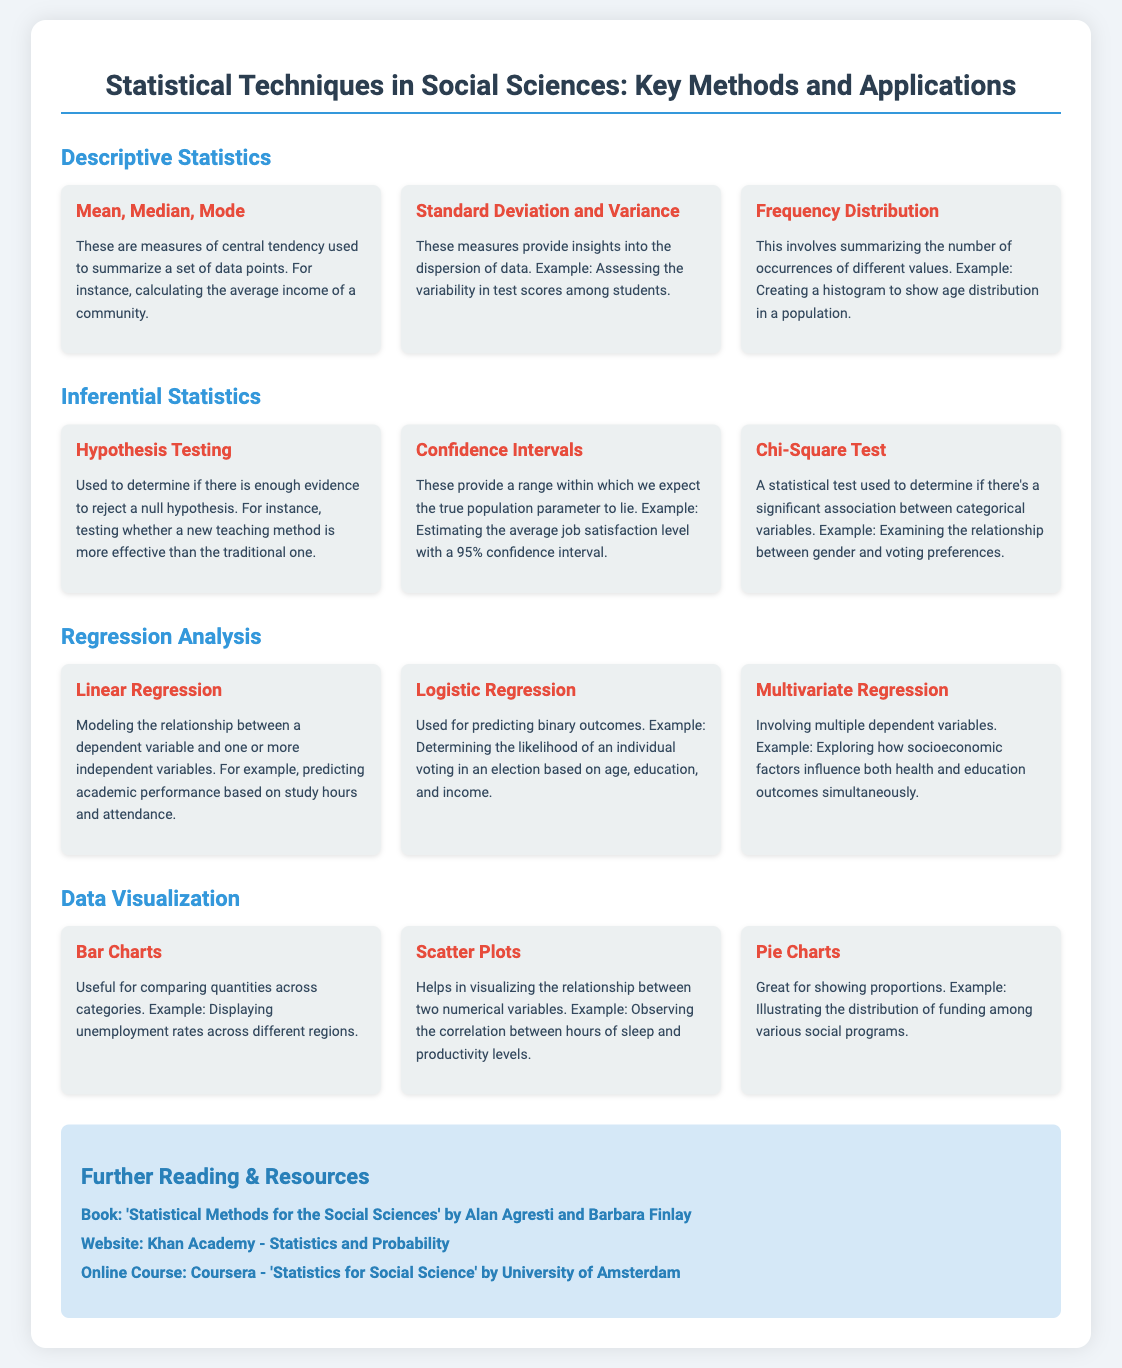What are the three measures of central tendency mentioned? The document lists "Mean, Median, Mode" as the measures of central tendency used to summarize data.
Answer: Mean, Median, Mode What type of statistical test is used to evaluate a null hypothesis? The poster describes "Hypothesis Testing" as a method to determine if there is enough evidence to reject a null hypothesis.
Answer: Hypothesis Testing What does a confidence interval provide? According to the document, "Confidence Intervals" provide a range within which the true population parameter is expected to lie.
Answer: A range What does linear regression model? The poster states that "Linear Regression" models the relationship between a dependent variable and one or more independent variables.
Answer: Relationship Which chart is recommended for comparing quantities across categories? The document recommends "Bar Charts" as a useful tool for comparing quantities across different categories.
Answer: Bar Charts What are the three types of regression analysis mentioned? The document lists "Linear Regression, Logistic Regression, Multivariate Regression" as the types of regression analysis discussed.
Answer: Linear Regression, Logistic Regression, Multivariate Regression What is the URL for Khan Academy's statistics resources? The document provides a link to Khan Academy for statistics and probability resources, which is mentioned as a website in the resources section.
Answer: https://www.khanacademy.org/math/statistics-probability How many statistical techniques are highlighted in the poster? The poster includes four main sections discussing different statistical techniques: Descriptive Statistics, Inferential Statistics, Regression Analysis, and Data Visualization.
Answer: Four What color is used for the headings in the resources section? The resources section headings are colored "blue" as indicated in the document's style section.
Answer: Blue 